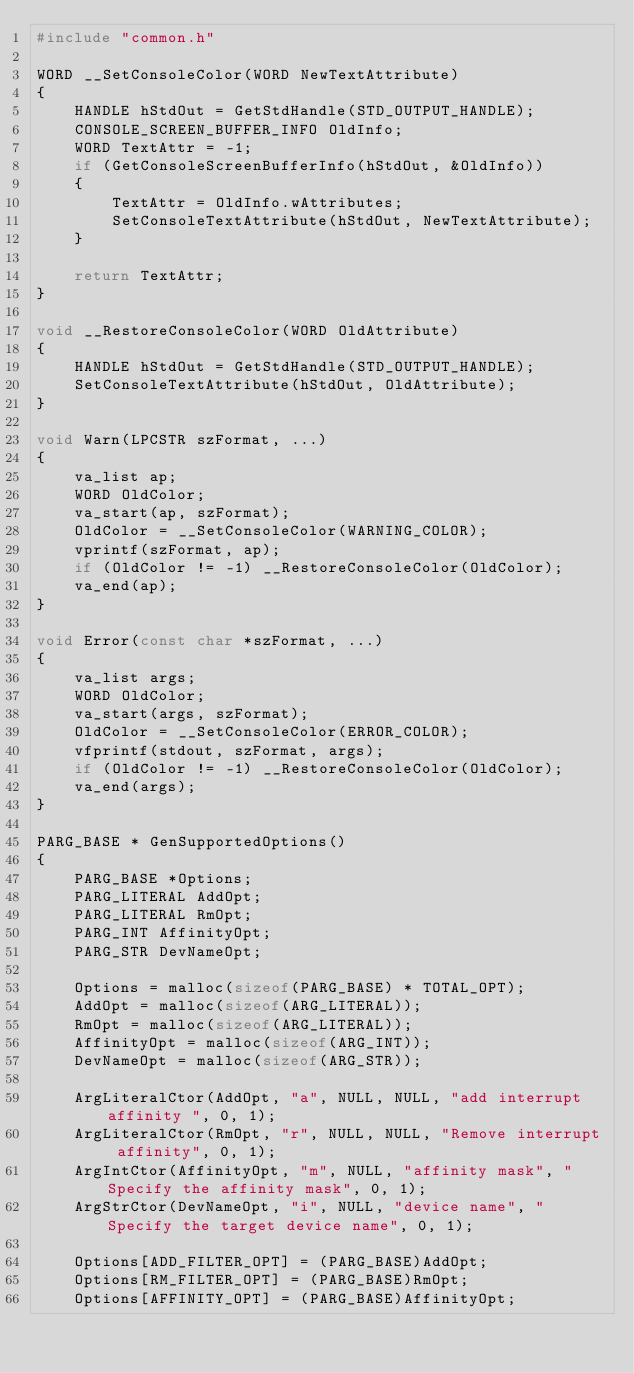Convert code to text. <code><loc_0><loc_0><loc_500><loc_500><_C_>#include "common.h"

WORD __SetConsoleColor(WORD NewTextAttribute)
{
    HANDLE hStdOut = GetStdHandle(STD_OUTPUT_HANDLE);
    CONSOLE_SCREEN_BUFFER_INFO OldInfo;
    WORD TextAttr = -1;
    if (GetConsoleScreenBufferInfo(hStdOut, &OldInfo))
    {
        TextAttr = OldInfo.wAttributes;
        SetConsoleTextAttribute(hStdOut, NewTextAttribute);
    }
    
    return TextAttr;
}

void __RestoreConsoleColor(WORD OldAttribute)
{
    HANDLE hStdOut = GetStdHandle(STD_OUTPUT_HANDLE);
    SetConsoleTextAttribute(hStdOut, OldAttribute);
}

void Warn(LPCSTR szFormat, ...)
{
    va_list ap;
    WORD OldColor;
    va_start(ap, szFormat);
    OldColor = __SetConsoleColor(WARNING_COLOR);
    vprintf(szFormat, ap);
    if (OldColor != -1) __RestoreConsoleColor(OldColor);
    va_end(ap);
}

void Error(const char *szFormat, ...)
{
    va_list args;
    WORD OldColor;
    va_start(args, szFormat);
    OldColor = __SetConsoleColor(ERROR_COLOR);
    vfprintf(stdout, szFormat, args);
    if (OldColor != -1) __RestoreConsoleColor(OldColor);
    va_end(args);
}

PARG_BASE * GenSupportedOptions()
{
    PARG_BASE *Options;
    PARG_LITERAL AddOpt;
    PARG_LITERAL RmOpt;
    PARG_INT AffinityOpt;
    PARG_STR DevNameOpt;

    Options = malloc(sizeof(PARG_BASE) * TOTAL_OPT);
    AddOpt = malloc(sizeof(ARG_LITERAL));
    RmOpt = malloc(sizeof(ARG_LITERAL));    
    AffinityOpt = malloc(sizeof(ARG_INT));
    DevNameOpt = malloc(sizeof(ARG_STR));

    ArgLiteralCtor(AddOpt, "a", NULL, NULL, "add interrupt affinity ", 0, 1);
    ArgLiteralCtor(RmOpt, "r", NULL, NULL, "Remove interrupt affinity", 0, 1);
    ArgIntCtor(AffinityOpt, "m", NULL, "affinity mask", "Specify the affinity mask", 0, 1);
    ArgStrCtor(DevNameOpt, "i", NULL, "device name", "Specify the target device name", 0, 1);
    
    Options[ADD_FILTER_OPT] = (PARG_BASE)AddOpt;
    Options[RM_FILTER_OPT] = (PARG_BASE)RmOpt;
    Options[AFFINITY_OPT] = (PARG_BASE)AffinityOpt;</code> 